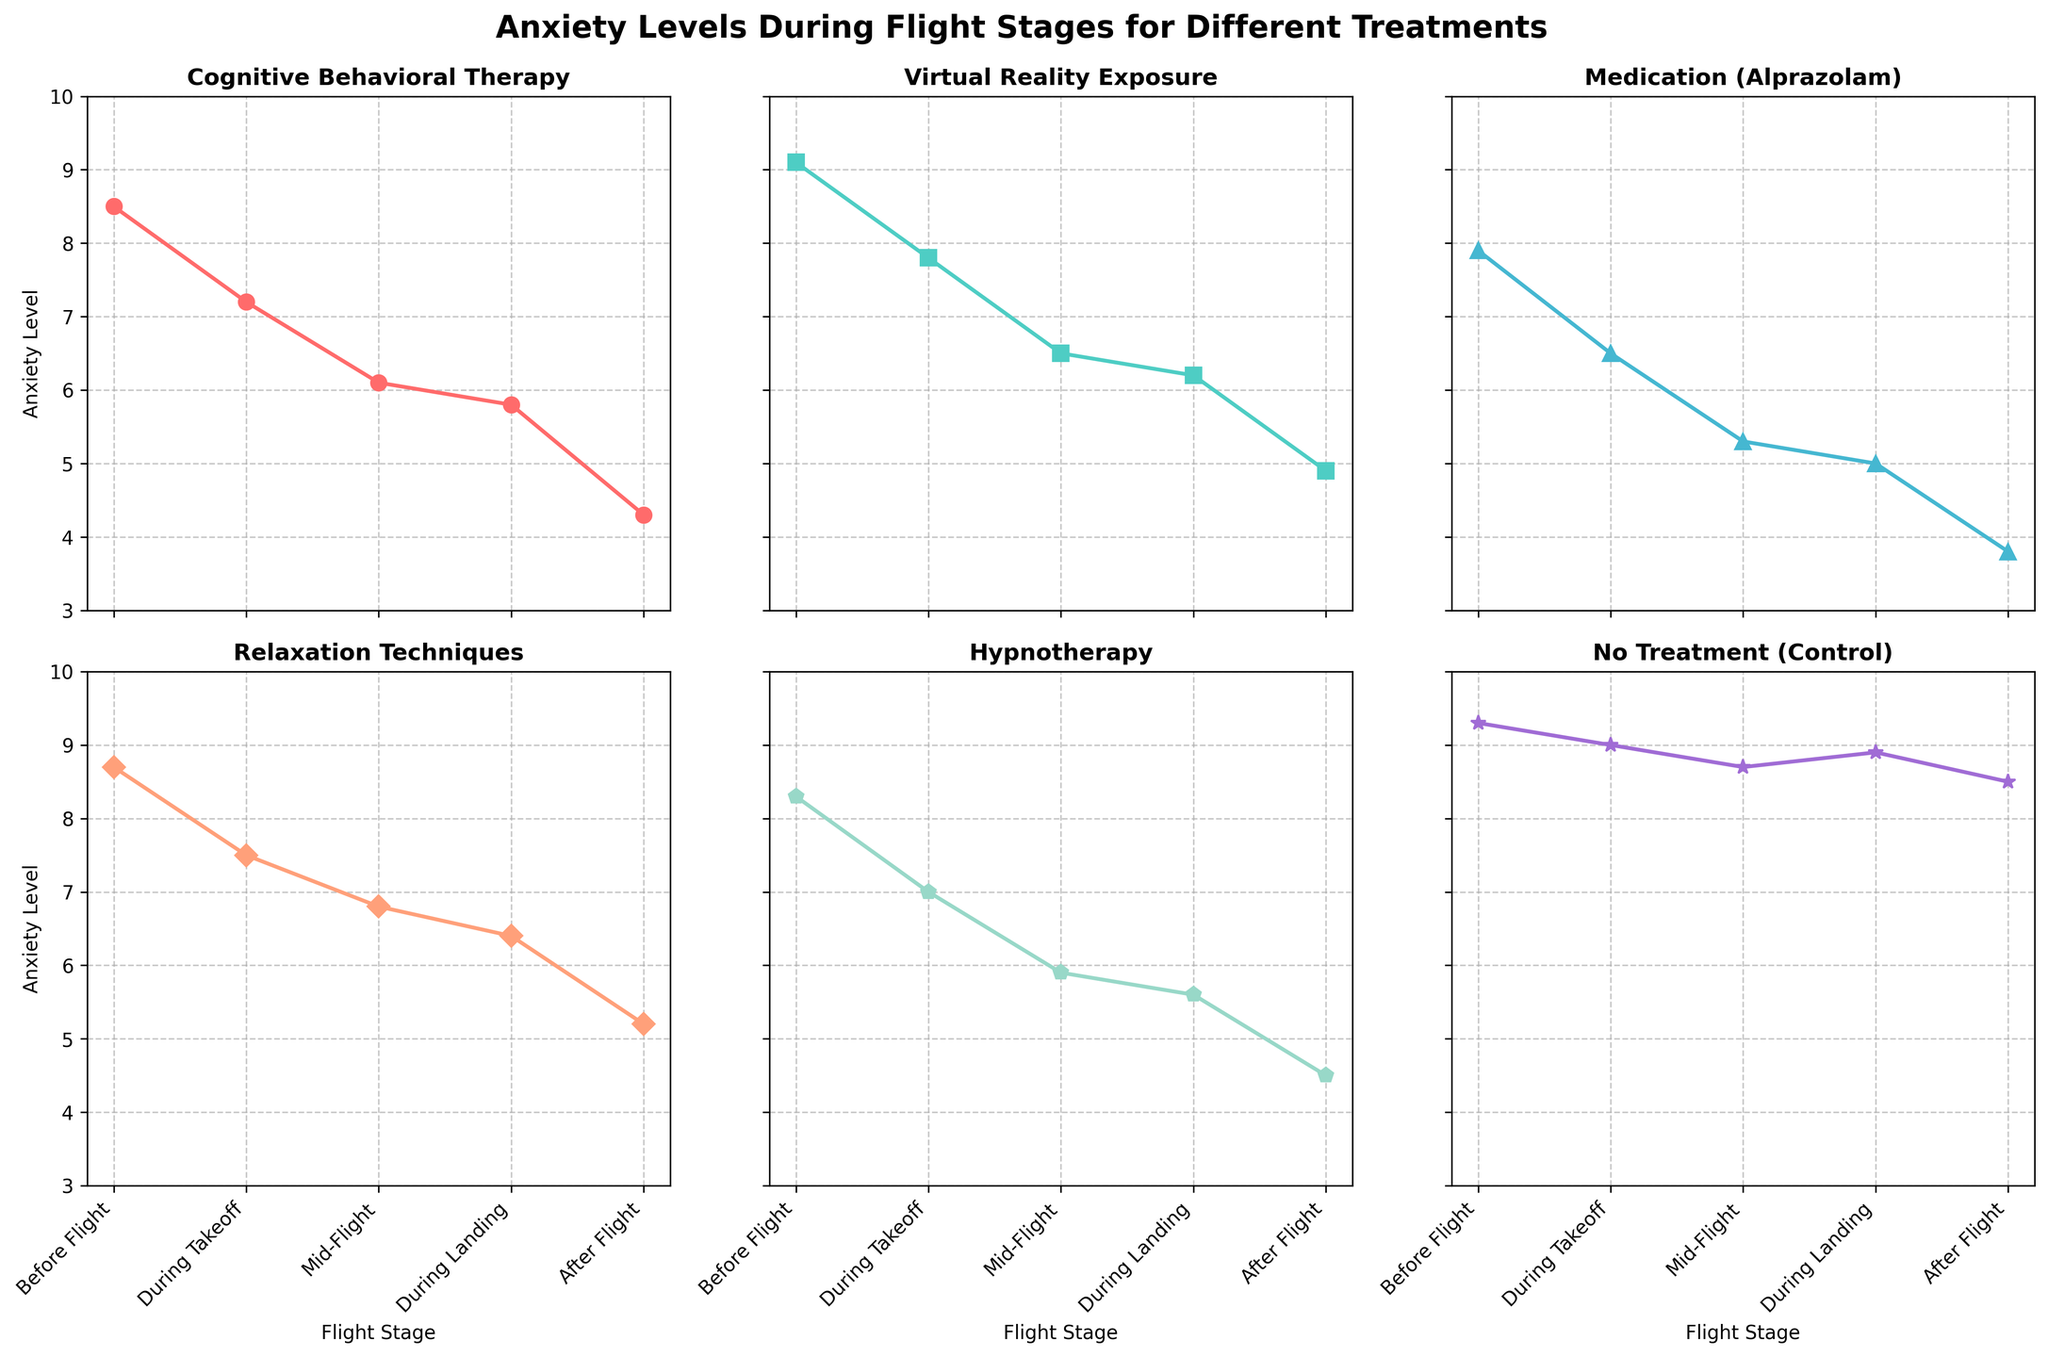What are the anxiety levels for individuals undergoing Hypnotherapy at "Before Flight" and "After Flight"? The figure presents the anxiety levels of different treatments at various flight stages. To find the anxiety levels for Hypnotherapy, look at the specific plot for Hypnotherapy and read the values at "Before Flight" and "After Flight". The anxiety levels are 8.3 (Before Flight) and 4.5 (After Flight).
Answer: 8.3 and 4.5 Which treatment exhibits the highest anxiety level "During Takeoff"? First, identify the "During Takeoff" stage for all treatments in the figure. Compare the values to determine the highest anxiety level, which is found to be for the "No Treatment (Control)" group with a level of 9.0.
Answer: No Treatment (Control) What is the average anxiety level "During Landing" across all treatments? Extract the anxiety levels "During Landing" from each treatment plot: 5.8 (CBT), 6.2 (VR Exposure), 5.0 (Medication), 6.4 (Relaxation), 5.6 (Hypnotherapy), 8.9 (Control). Sum these values (5.8 + 6.2 + 5.0 + 6.4 + 5.6 + 8.9 = 37.9). Then divide by the number of treatments (37.9 / 6). The average anxiety level is approximately 6.32.
Answer: 6.32 How does the anxiety level "After Flight" for Relaxation Techniques compare to Medication (Alprazolam)? Look at the "After Flight" anxiety levels for Relaxation Techniques and Medication (Alprazolam) in the respective plots. Relaxation Techniques has an anxiety level of 5.2, while Medication (Alprazolam) has a level of 3.8. Compare the two values: 5.2 (Relaxation Techniques) is higher than 3.8 (Medication).
Answer: Relaxation Techniques is higher What is the overall trend in anxiety levels for Virtual Reality Exposure from "Before Flight" to "After Flight"? View the plot for Virtual Reality Exposure. Observe the anxiety levels at each of the five flight stages: 9.1 (Before), 7.8 (During Takeoff), 6.5 (Mid-Flight), 6.2 (During Landing), 4.9 (After). The trend shows a consistent decrease in anxiety levels from "Before Flight" to "After Flight".
Answer: Decreasing 